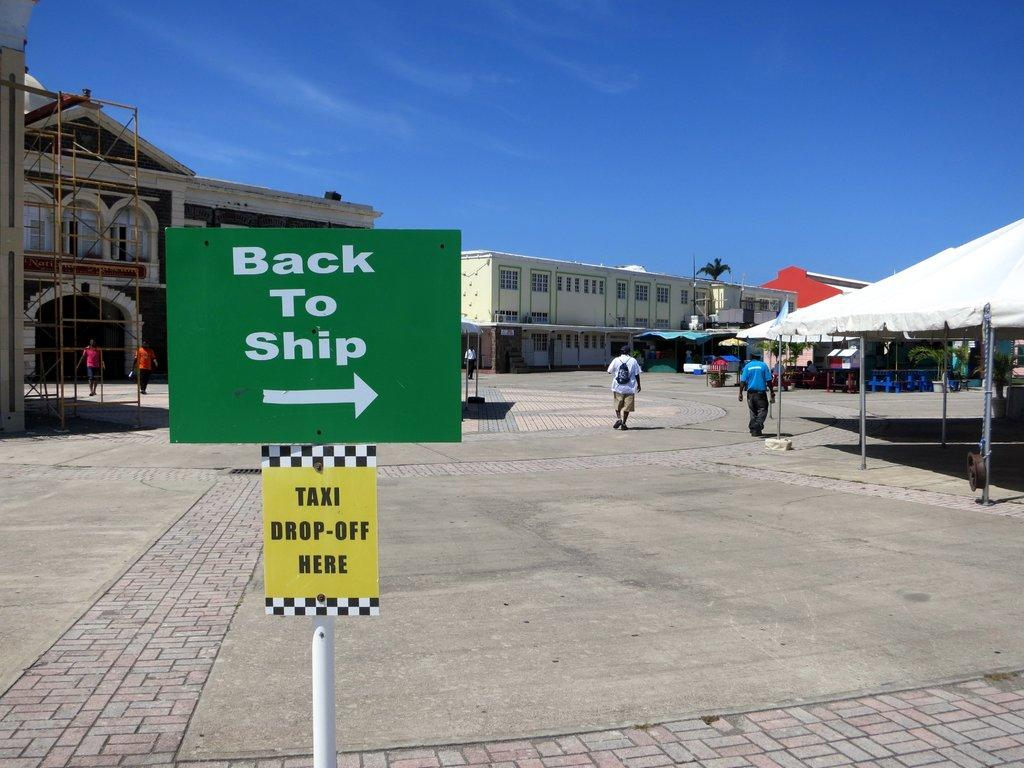What is located in the foreground of the image? There is a board in the foreground of the image. What can be seen in the background of the image? There are buildings in the background of the image. Where is the tent positioned in the image? The tent is on the right side of the image. Can you describe the people in the image? Yes, there are people in the image. What is the condition of the sky in the image? The sky is clear in the image. What type of silver object is visible in the mouth of one of the people in the image? There is no silver object visible in the mouth of any person in the image. What kind of system is being used by the people in the image? The provided facts do not mention any system being used by the people in the image. 